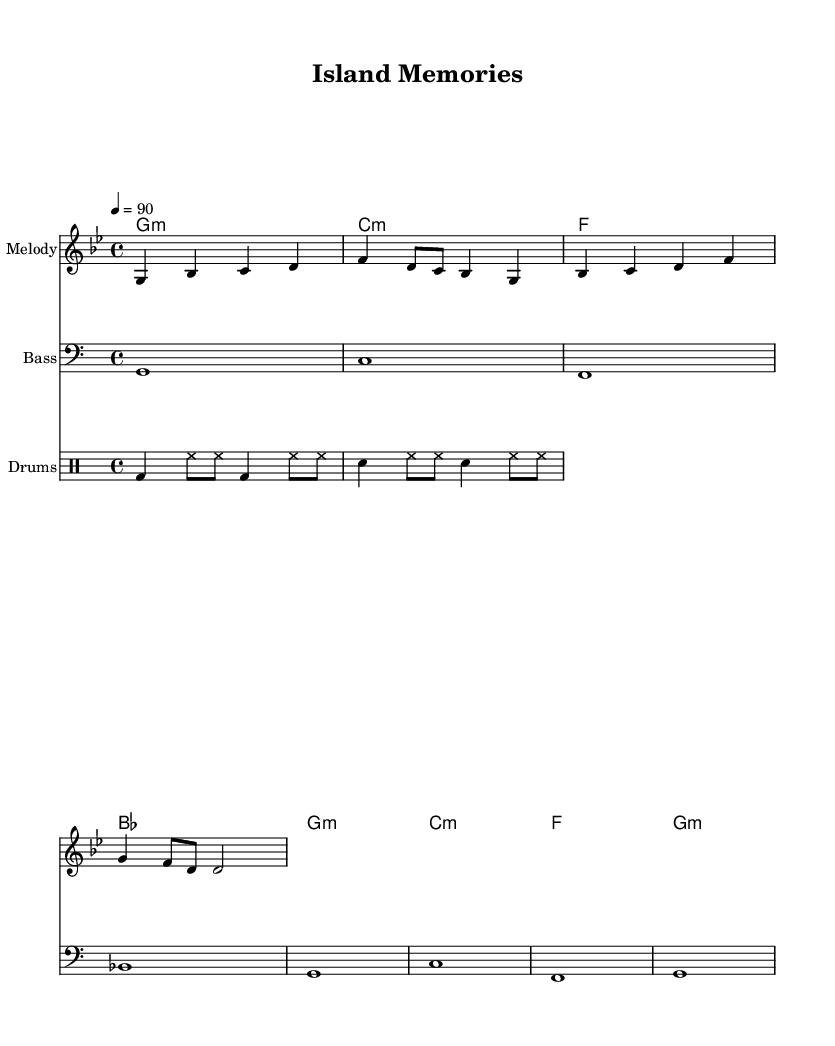What is the key signature of this music? The key signature is G minor, which has two flats. One is B flat and the other is E flat, indicated at the beginning of the staff.
Answer: G minor What is the time signature of this piece? The time signature is 4/4, which means there are four beats in each measure and the quarter note gets one beat. This is shown at the beginning of the sheet music.
Answer: 4/4 What is the tempo marking for this piece? The tempo marking is 90 beats per minute, which is indicated above the staff. This specifies the speed at which the piece should be played.
Answer: 90 How many measures are in the melody section? The melody consists of four measures, which can be counted by looking at the vertical lines dividing the musical staff into sections.
Answer: 4 What are the instruments used in this score? The instruments included in this score are Melody, Bass, and Drums, identified at the beginning of each staff. This highlights the different roles each instrument plays.
Answer: Melody, Bass, Drums What type of music does this sheet represent? This sheet represents Hip Hop, characterized by its rhythmic and lyrical style, indicated by the style of the melody and the drum patterns that suggest a rap structure.
Answer: Hip Hop 